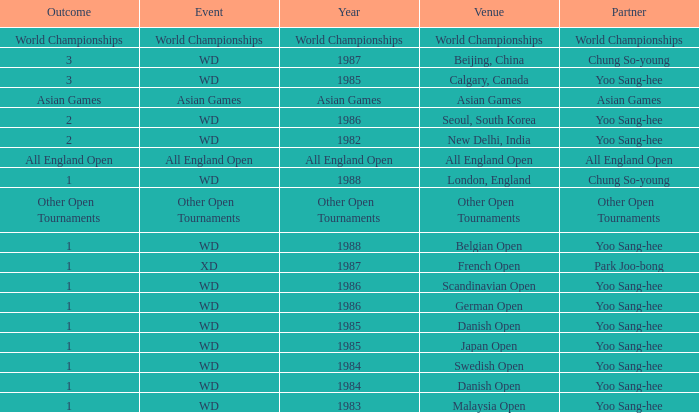In what year did yoo sang-hee participate as a partner in the german open? 1986.0. 